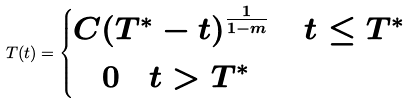<formula> <loc_0><loc_0><loc_500><loc_500>T ( t ) = \begin{cases} C ( T ^ { \ast } - t ) ^ { \frac { 1 } { 1 - m } } \quad \, t \leq T ^ { \ast } \\ \quad 0 \quad t > T ^ { \ast } \end{cases}</formula> 